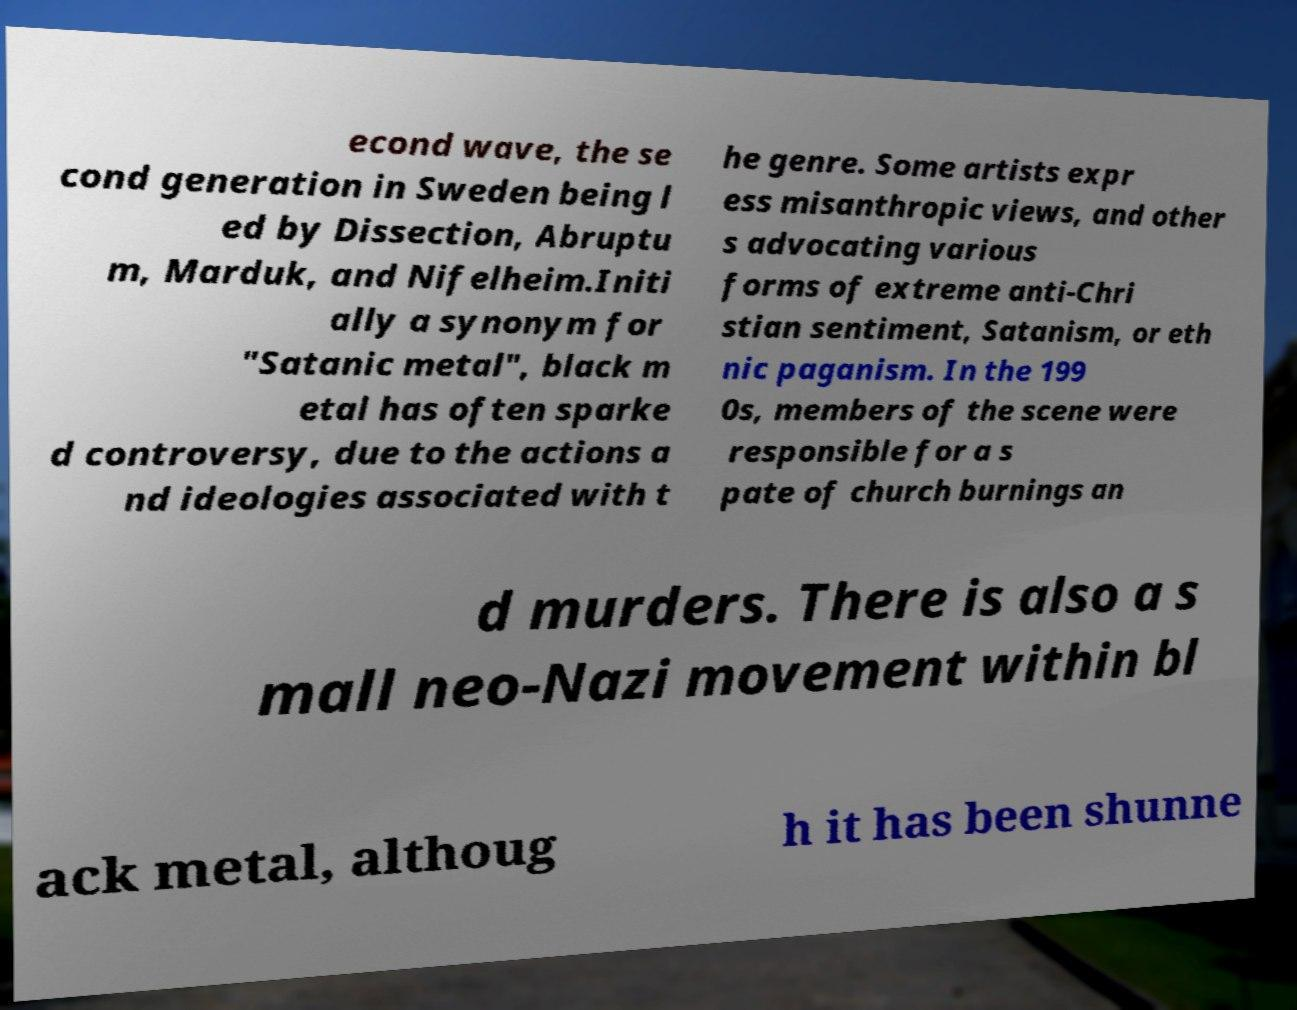There's text embedded in this image that I need extracted. Can you transcribe it verbatim? econd wave, the se cond generation in Sweden being l ed by Dissection, Abruptu m, Marduk, and Nifelheim.Initi ally a synonym for "Satanic metal", black m etal has often sparke d controversy, due to the actions a nd ideologies associated with t he genre. Some artists expr ess misanthropic views, and other s advocating various forms of extreme anti-Chri stian sentiment, Satanism, or eth nic paganism. In the 199 0s, members of the scene were responsible for a s pate of church burnings an d murders. There is also a s mall neo-Nazi movement within bl ack metal, althoug h it has been shunne 